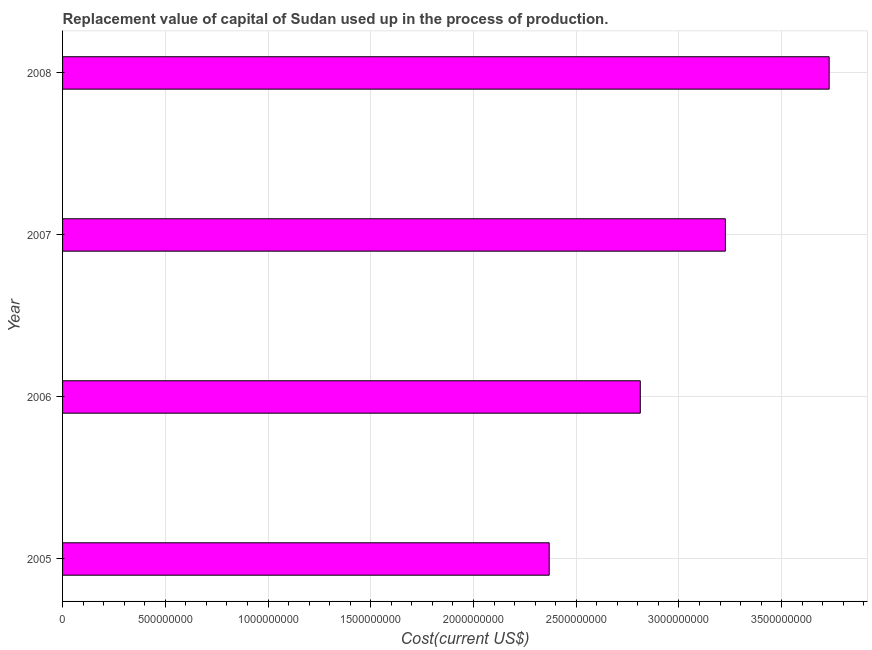Does the graph contain any zero values?
Your answer should be very brief. No. What is the title of the graph?
Your answer should be compact. Replacement value of capital of Sudan used up in the process of production. What is the label or title of the X-axis?
Make the answer very short. Cost(current US$). What is the consumption of fixed capital in 2007?
Your answer should be very brief. 3.23e+09. Across all years, what is the maximum consumption of fixed capital?
Provide a short and direct response. 3.73e+09. Across all years, what is the minimum consumption of fixed capital?
Make the answer very short. 2.37e+09. In which year was the consumption of fixed capital maximum?
Give a very brief answer. 2008. In which year was the consumption of fixed capital minimum?
Provide a short and direct response. 2005. What is the sum of the consumption of fixed capital?
Your response must be concise. 1.21e+1. What is the difference between the consumption of fixed capital in 2005 and 2007?
Ensure brevity in your answer.  -8.57e+08. What is the average consumption of fixed capital per year?
Ensure brevity in your answer.  3.03e+09. What is the median consumption of fixed capital?
Give a very brief answer. 3.02e+09. What is the ratio of the consumption of fixed capital in 2007 to that in 2008?
Make the answer very short. 0.86. What is the difference between the highest and the second highest consumption of fixed capital?
Keep it short and to the point. 5.05e+08. What is the difference between the highest and the lowest consumption of fixed capital?
Give a very brief answer. 1.36e+09. How many bars are there?
Your answer should be very brief. 4. How many years are there in the graph?
Provide a succinct answer. 4. What is the difference between two consecutive major ticks on the X-axis?
Make the answer very short. 5.00e+08. What is the Cost(current US$) of 2005?
Provide a short and direct response. 2.37e+09. What is the Cost(current US$) in 2006?
Keep it short and to the point. 2.81e+09. What is the Cost(current US$) in 2007?
Offer a terse response. 3.23e+09. What is the Cost(current US$) of 2008?
Ensure brevity in your answer.  3.73e+09. What is the difference between the Cost(current US$) in 2005 and 2006?
Provide a short and direct response. -4.43e+08. What is the difference between the Cost(current US$) in 2005 and 2007?
Give a very brief answer. -8.57e+08. What is the difference between the Cost(current US$) in 2005 and 2008?
Provide a short and direct response. -1.36e+09. What is the difference between the Cost(current US$) in 2006 and 2007?
Your answer should be compact. -4.14e+08. What is the difference between the Cost(current US$) in 2006 and 2008?
Provide a short and direct response. -9.19e+08. What is the difference between the Cost(current US$) in 2007 and 2008?
Your response must be concise. -5.05e+08. What is the ratio of the Cost(current US$) in 2005 to that in 2006?
Your response must be concise. 0.84. What is the ratio of the Cost(current US$) in 2005 to that in 2007?
Provide a succinct answer. 0.73. What is the ratio of the Cost(current US$) in 2005 to that in 2008?
Offer a very short reply. 0.64. What is the ratio of the Cost(current US$) in 2006 to that in 2007?
Offer a terse response. 0.87. What is the ratio of the Cost(current US$) in 2006 to that in 2008?
Your answer should be compact. 0.75. What is the ratio of the Cost(current US$) in 2007 to that in 2008?
Give a very brief answer. 0.86. 